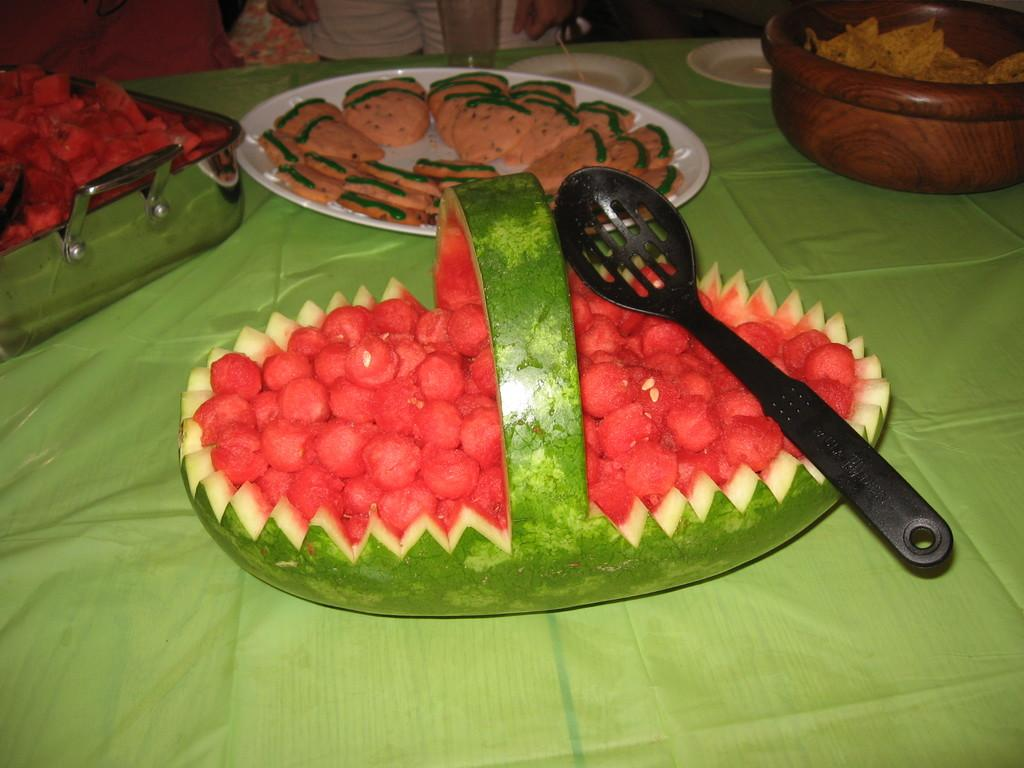What type of fruit is visible in the image? There is a watermelon in the image. What utensil is present in the image? There is a spoon in the image. Where are the watermelon and spoon located? Both the watermelon and spoon are placed on a table. What other dishware is present in the image? There is a plate and a bowl in the image. What is the vessel filled with in the image? There is a vessel filled with food in the image. How close is the table to the person in the image? The table is located near a person. What type of art can be seen hanging on the wall behind the person in the image? There is no mention of any art or wall in the provided facts, so it cannot be determined from the image. 